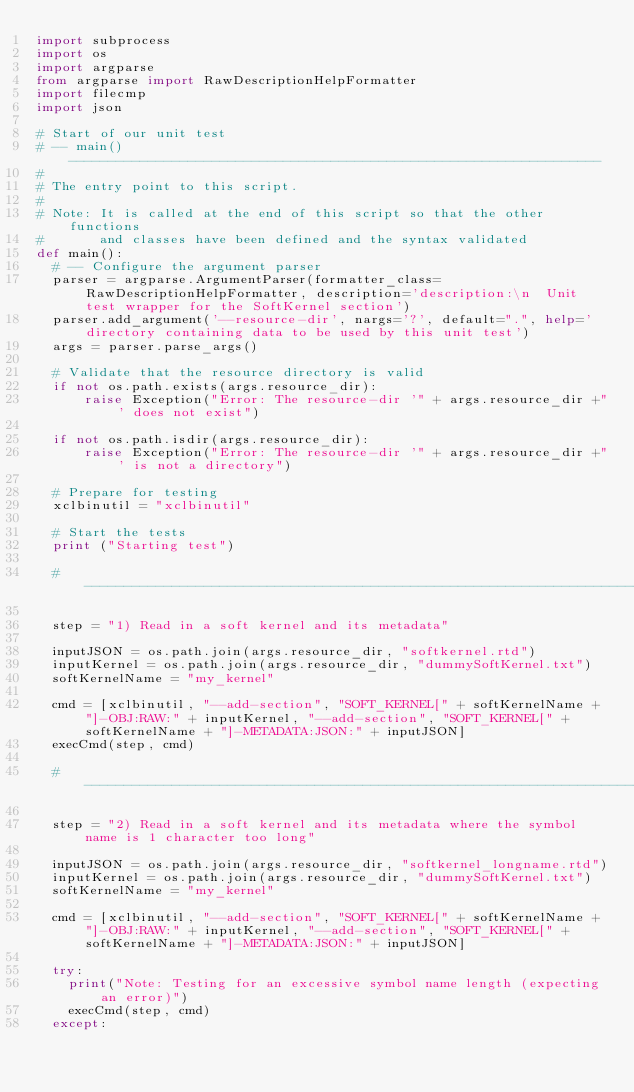Convert code to text. <code><loc_0><loc_0><loc_500><loc_500><_Python_>import subprocess
import os
import argparse
from argparse import RawDescriptionHelpFormatter
import filecmp
import json

# Start of our unit test
# -- main() -------------------------------------------------------------------
#
# The entry point to this script.
#
# Note: It is called at the end of this script so that the other functions
#       and classes have been defined and the syntax validated
def main():
  # -- Configure the argument parser
  parser = argparse.ArgumentParser(formatter_class=RawDescriptionHelpFormatter, description='description:\n  Unit test wrapper for the SoftKernel section')
  parser.add_argument('--resource-dir', nargs='?', default=".", help='directory containing data to be used by this unit test')
  args = parser.parse_args()

  # Validate that the resource directory is valid
  if not os.path.exists(args.resource_dir):
      raise Exception("Error: The resource-dir '" + args.resource_dir +"' does not exist")

  if not os.path.isdir(args.resource_dir):
      raise Exception("Error: The resource-dir '" + args.resource_dir +"' is not a directory")

  # Prepare for testing
  xclbinutil = "xclbinutil"

  # Start the tests
  print ("Starting test")

  # ---------------------------------------------------------------------------

  step = "1) Read in a soft kernel and its metadata"

  inputJSON = os.path.join(args.resource_dir, "softkernel.rtd")
  inputKernel = os.path.join(args.resource_dir, "dummySoftKernel.txt")
  softKernelName = "my_kernel"

  cmd = [xclbinutil, "--add-section", "SOFT_KERNEL[" + softKernelName + "]-OBJ:RAW:" + inputKernel, "--add-section", "SOFT_KERNEL[" + softKernelName + "]-METADATA:JSON:" + inputJSON]
  execCmd(step, cmd)

  # ---------------------------------------------------------------------------

  step = "2) Read in a soft kernel and its metadata where the symbol name is 1 character too long"

  inputJSON = os.path.join(args.resource_dir, "softkernel_longname.rtd")
  inputKernel = os.path.join(args.resource_dir, "dummySoftKernel.txt")
  softKernelName = "my_kernel"

  cmd = [xclbinutil, "--add-section", "SOFT_KERNEL[" + softKernelName + "]-OBJ:RAW:" + inputKernel, "--add-section", "SOFT_KERNEL[" + softKernelName + "]-METADATA:JSON:" + inputJSON]

  try:
    print("Note: Testing for an excessive symbol name length (expecting an error)")
    execCmd(step, cmd)
  except:</code> 